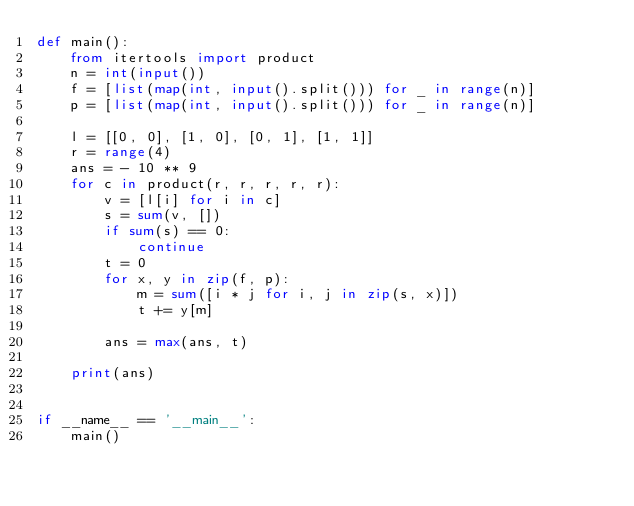<code> <loc_0><loc_0><loc_500><loc_500><_Python_>def main():
    from itertools import product
    n = int(input())
    f = [list(map(int, input().split())) for _ in range(n)]
    p = [list(map(int, input().split())) for _ in range(n)]

    l = [[0, 0], [1, 0], [0, 1], [1, 1]]
    r = range(4)
    ans = - 10 ** 9
    for c in product(r, r, r, r, r):
        v = [l[i] for i in c]
        s = sum(v, [])
        if sum(s) == 0:
            continue
        t = 0
        for x, y in zip(f, p):
            m = sum([i * j for i, j in zip(s, x)])
            t += y[m]

        ans = max(ans, t)

    print(ans)


if __name__ == '__main__':
    main()
</code> 